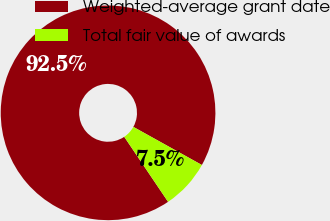Convert chart to OTSL. <chart><loc_0><loc_0><loc_500><loc_500><pie_chart><fcel>Weighted-average grant date<fcel>Total fair value of awards<nl><fcel>92.52%<fcel>7.48%<nl></chart> 